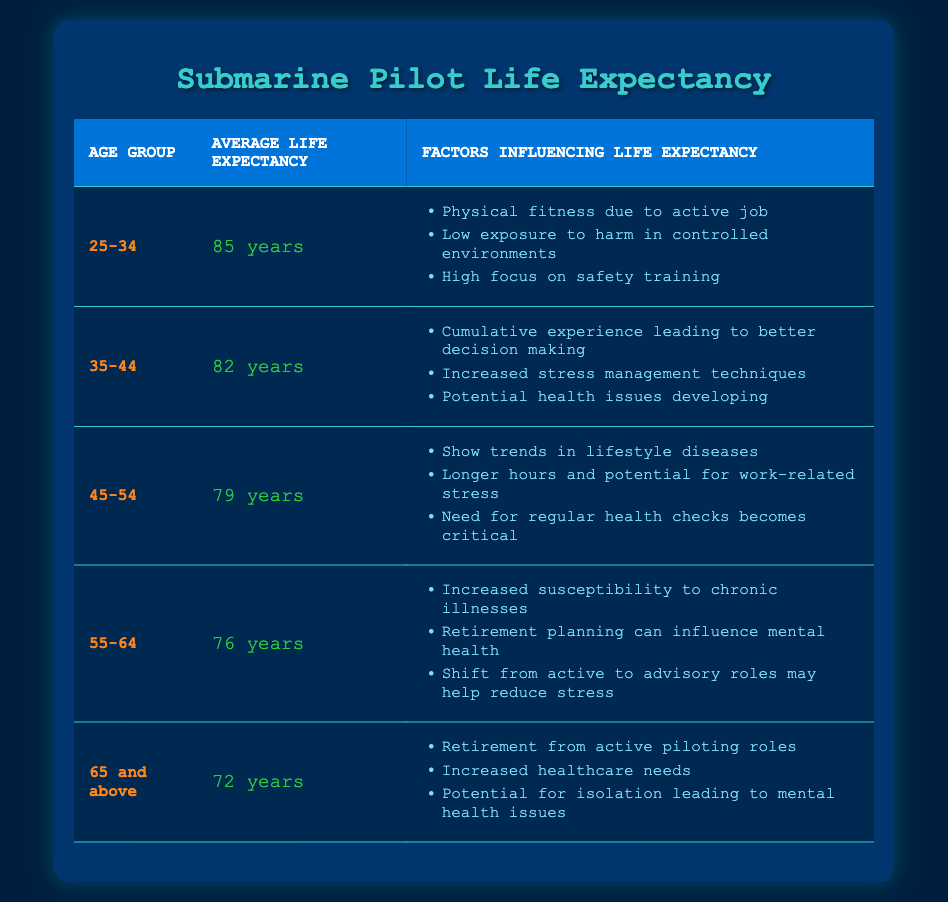What is the average life expectancy for the age group 25-34? The table shows that the average life expectancy for the age group 25-34 is listed directly under the “Average Life Expectancy” column. This value is 85 years.
Answer: 85 years Which age group has the lowest average life expectancy? By examining the "Average Life Expectancy" values in the table, the lowest average is 72 years, which corresponds to the age group "65 and above."
Answer: 65 and above What are the factors influencing life expectancy for the age group 45-54? The table provides a list of factors for each age group. For 45-54, the factors are "Show trends in lifestyle diseases," "Longer hours and potential for work-related stress," and "Need for regular health checks becomes critical."
Answer: Show trends in lifestyle diseases, Longer hours and potential for work-related stress, Need for regular health checks becomes critical If you compare the average life expectancy of age groups 35-44 and 55-64, what is the difference? From the table, the average life expectancy for 35-44 is 82 years, and for 55-64, it’s 76 years. To find the difference, you subtract 76 from 82. The calculation is 82 - 76 = 6 years.
Answer: 6 years Is it true that retirement can influence mental health for submarine pilots aged 55-64? The table states that for the age group 55-64, one of the factors influencing life expectancy is "Retirement planning can influence mental health.” Therefore, the statement is true.
Answer: Yes What is the average life expectancy for submarine pilots aged 45-54, and what factor influences the need for regular health checks? The average life expectancy for pilots aged 45-54 is 79 years. The factor that influences the need for regular health checks is noted in the table: "Need for regular health checks becomes critical."
Answer: 79 years; Need for regular health checks becomes critical Which age group experiences increased susceptibility to chronic illnesses? According to the table, the age group 55-64 experiences increased susceptibility to chronic illnesses as stated in the corresponding factors section.
Answer: 55-64 What is the average life expectancy of submarine pilots in the age group 65 and above, and what healthcare needs are mentioned? The average life expectancy for this group is 72 years. The table mentions increased healthcare needs as one of the influencing factors.
Answer: 72 years; Increased healthcare needs 